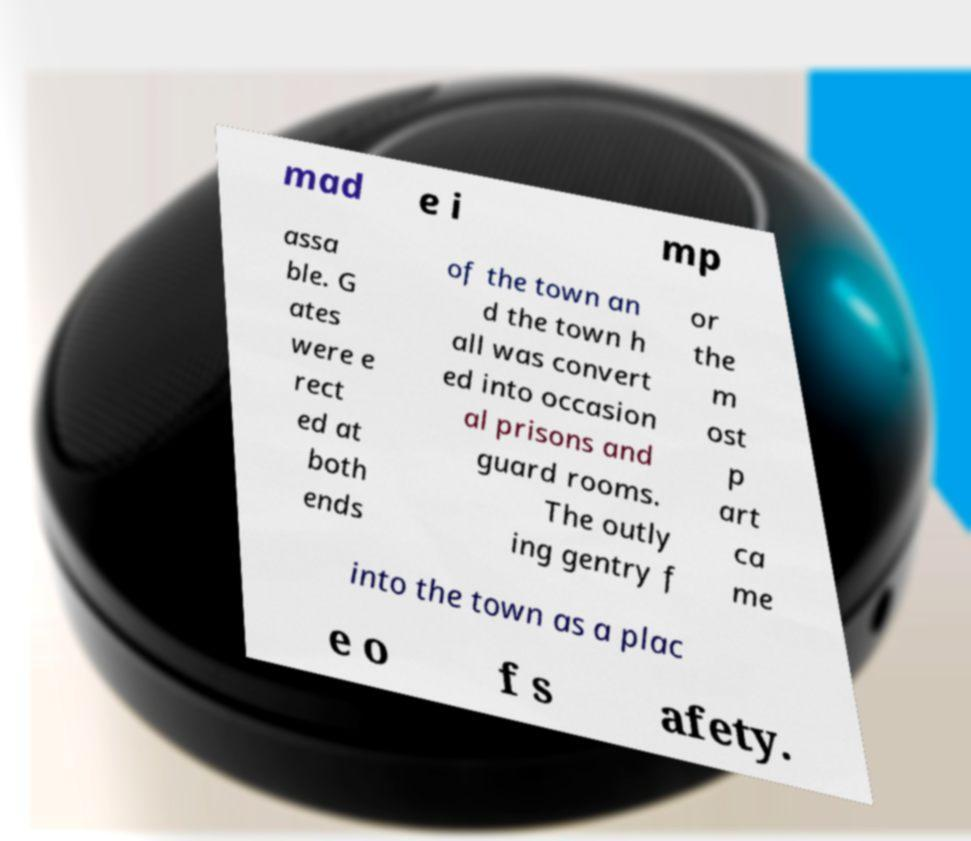Could you assist in decoding the text presented in this image and type it out clearly? mad e i mp assa ble. G ates were e rect ed at both ends of the town an d the town h all was convert ed into occasion al prisons and guard rooms. The outly ing gentry f or the m ost p art ca me into the town as a plac e o f s afety. 